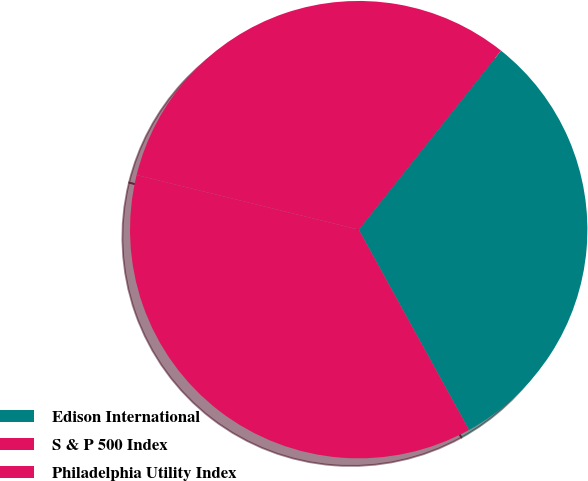Convert chart. <chart><loc_0><loc_0><loc_500><loc_500><pie_chart><fcel>Edison International<fcel>S & P 500 Index<fcel>Philadelphia Utility Index<nl><fcel>31.3%<fcel>31.85%<fcel>36.85%<nl></chart> 